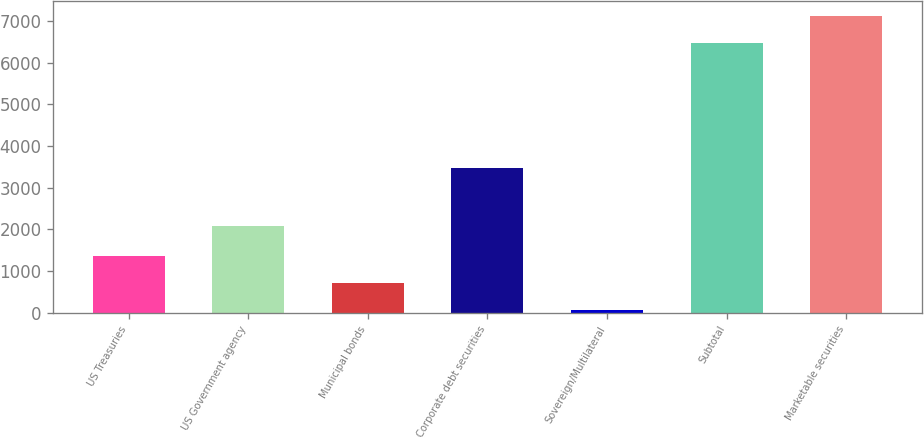Convert chart. <chart><loc_0><loc_0><loc_500><loc_500><bar_chart><fcel>US Treasuries<fcel>US Government agency<fcel>Municipal bonds<fcel>Corporate debt securities<fcel>Sovereign/Multilateral<fcel>Subtotal<fcel>Marketable securities<nl><fcel>1353.6<fcel>2089<fcel>713.3<fcel>3478<fcel>73<fcel>6476<fcel>7116.3<nl></chart> 